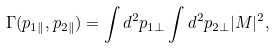<formula> <loc_0><loc_0><loc_500><loc_500>\Gamma ( p _ { 1 \| } , p _ { 2 \| } ) = \int d ^ { 2 } p _ { 1 \perp } \int d ^ { 2 } p _ { 2 \perp } | M | ^ { 2 } ,</formula> 